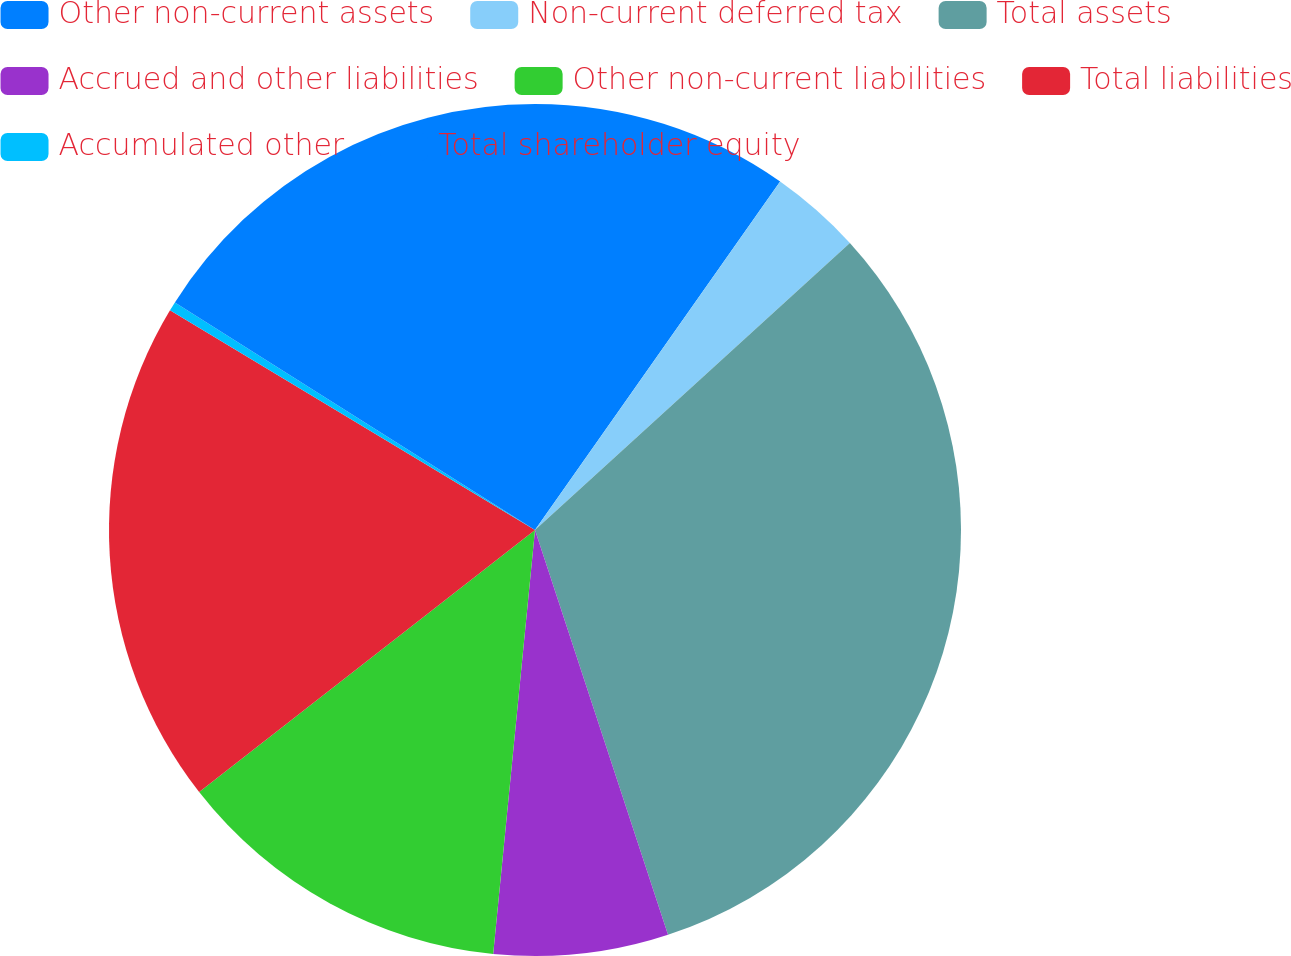Convert chart to OTSL. <chart><loc_0><loc_0><loc_500><loc_500><pie_chart><fcel>Other non-current assets<fcel>Non-current deferred tax<fcel>Total assets<fcel>Accrued and other liabilities<fcel>Other non-current liabilities<fcel>Total liabilities<fcel>Accumulated other<fcel>Total shareholder equity<nl><fcel>9.76%<fcel>3.48%<fcel>31.71%<fcel>6.62%<fcel>12.89%<fcel>19.17%<fcel>0.35%<fcel>16.03%<nl></chart> 